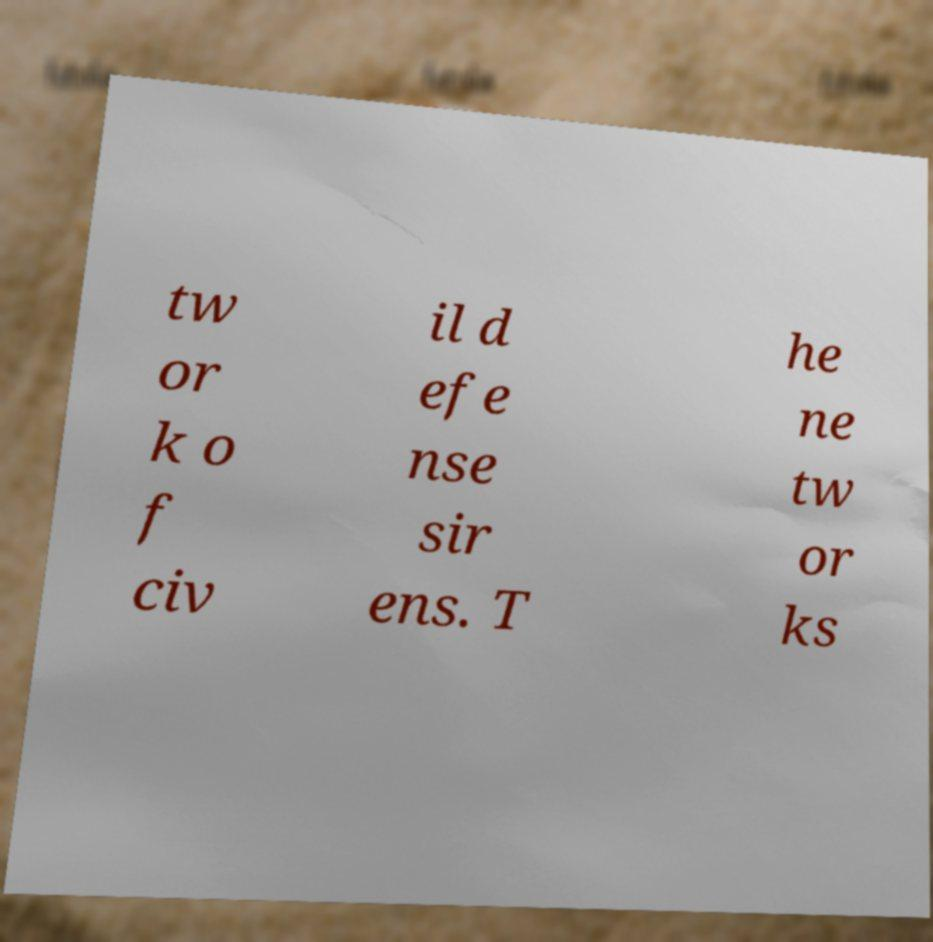What messages or text are displayed in this image? I need them in a readable, typed format. tw or k o f civ il d efe nse sir ens. T he ne tw or ks 